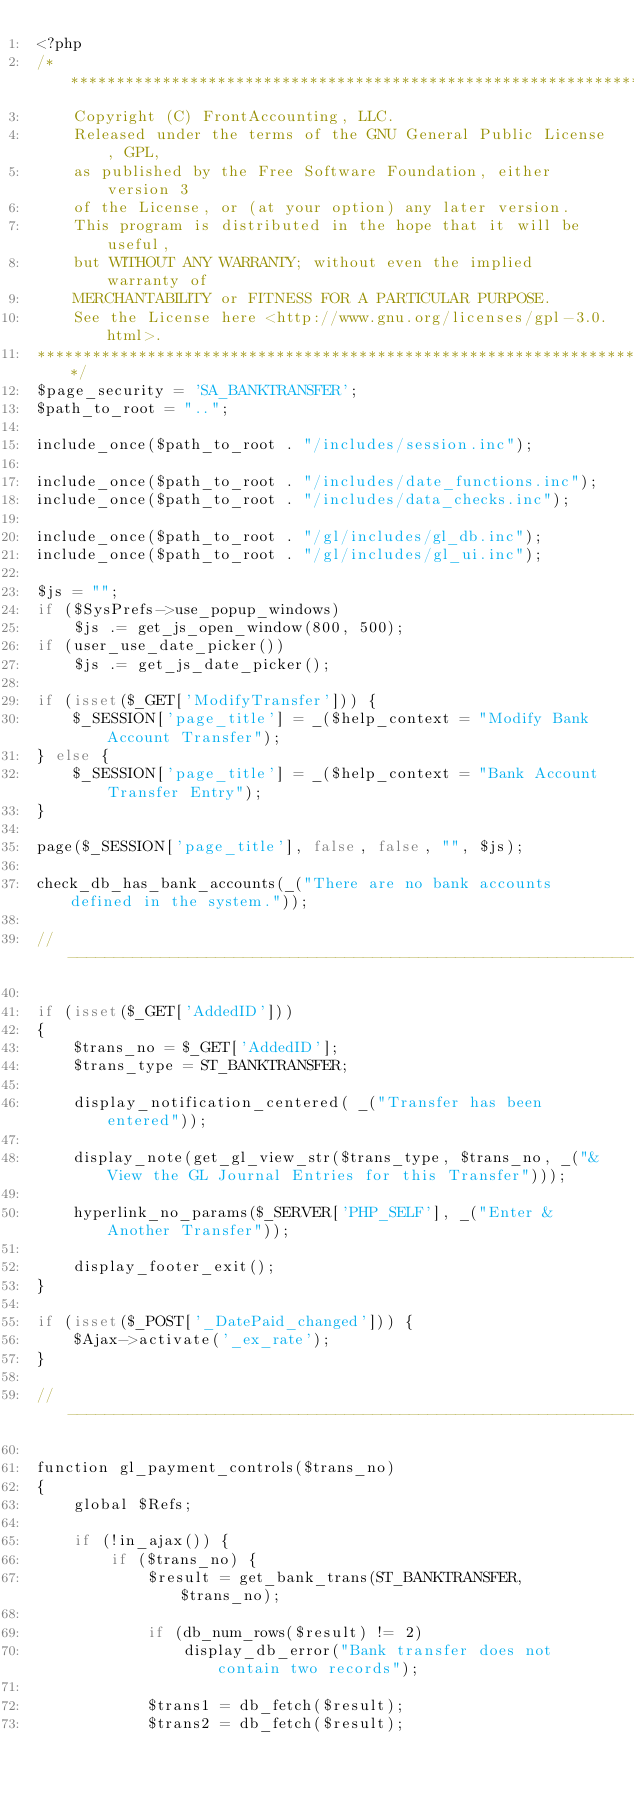<code> <loc_0><loc_0><loc_500><loc_500><_PHP_><?php
/**********************************************************************
    Copyright (C) FrontAccounting, LLC.
	Released under the terms of the GNU General Public License, GPL, 
	as published by the Free Software Foundation, either version 3 
	of the License, or (at your option) any later version.
    This program is distributed in the hope that it will be useful,
    but WITHOUT ANY WARRANTY; without even the implied warranty of
    MERCHANTABILITY or FITNESS FOR A PARTICULAR PURPOSE.  
    See the License here <http://www.gnu.org/licenses/gpl-3.0.html>.
***********************************************************************/
$page_security = 'SA_BANKTRANSFER';
$path_to_root = "..";

include_once($path_to_root . "/includes/session.inc");

include_once($path_to_root . "/includes/date_functions.inc");
include_once($path_to_root . "/includes/data_checks.inc");

include_once($path_to_root . "/gl/includes/gl_db.inc");
include_once($path_to_root . "/gl/includes/gl_ui.inc");

$js = "";
if ($SysPrefs->use_popup_windows)
	$js .= get_js_open_window(800, 500);
if (user_use_date_picker())
	$js .= get_js_date_picker();

if (isset($_GET['ModifyTransfer'])) {
	$_SESSION['page_title'] = _($help_context = "Modify Bank Account Transfer");
} else {
	$_SESSION['page_title'] = _($help_context = "Bank Account Transfer Entry");
}

page($_SESSION['page_title'], false, false, "", $js);

check_db_has_bank_accounts(_("There are no bank accounts defined in the system."));

//----------------------------------------------------------------------------------------

if (isset($_GET['AddedID'])) 
{
	$trans_no = $_GET['AddedID'];
	$trans_type = ST_BANKTRANSFER;

   	display_notification_centered( _("Transfer has been entered"));

	display_note(get_gl_view_str($trans_type, $trans_no, _("&View the GL Journal Entries for this Transfer")));

   	hyperlink_no_params($_SERVER['PHP_SELF'], _("Enter &Another Transfer"));

	display_footer_exit();
}

if (isset($_POST['_DatePaid_changed'])) {
	$Ajax->activate('_ex_rate');
}

//----------------------------------------------------------------------------------------

function gl_payment_controls($trans_no)
{
	global $Refs;
	
	if (!in_ajax()) {
		if ($trans_no) {
			$result = get_bank_trans(ST_BANKTRANSFER, $trans_no);

			if (db_num_rows($result) != 2)
				display_db_error("Bank transfer does not contain two records");

			$trans1 = db_fetch($result);
			$trans2 = db_fetch($result);
</code> 